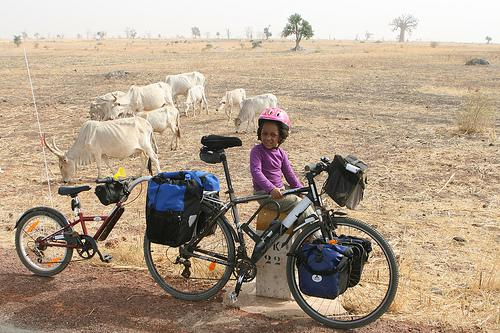Question: where is this photo taken?
Choices:
A. Field.
B. Park.
C. Yard.
D. Street.
Answer with the letter. Answer: A Question: how many people are shown?
Choices:
A. One.
B. Two.
C. Three.
D. Four.
Answer with the letter. Answer: A Question: who is behind the girl?
Choices:
A. Man.
B. Woman.
C. Cattle.
D. Cows.
Answer with the letter. Answer: D Question: how many tires does the bike have?
Choices:
A. Three.
B. One.
C. Two.
D. Four.
Answer with the letter. Answer: A Question: what color is the girls helmet?
Choices:
A. Red.
B. Pink.
C. White.
D. Blue.
Answer with the letter. Answer: B Question: what number is on the box the girl is sitting on?
Choices:
A. Three.
B. Twenty two.
C. Five.
D. Nine.
Answer with the letter. Answer: B 